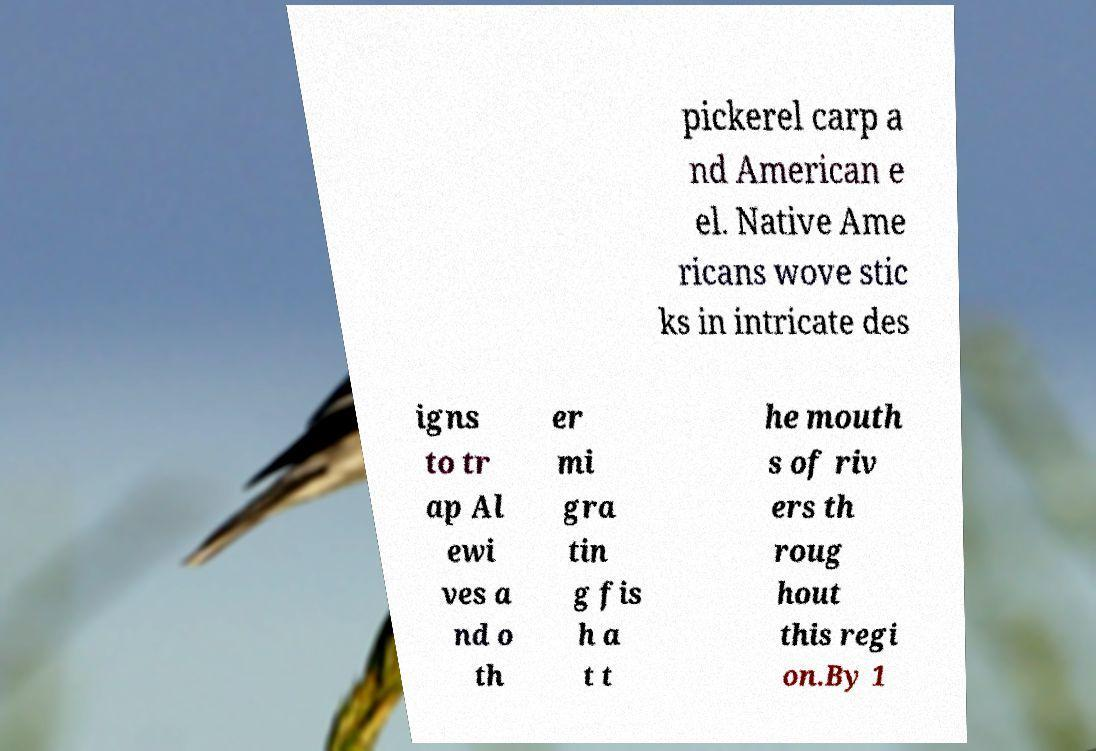Could you assist in decoding the text presented in this image and type it out clearly? pickerel carp a nd American e el. Native Ame ricans wove stic ks in intricate des igns to tr ap Al ewi ves a nd o th er mi gra tin g fis h a t t he mouth s of riv ers th roug hout this regi on.By 1 